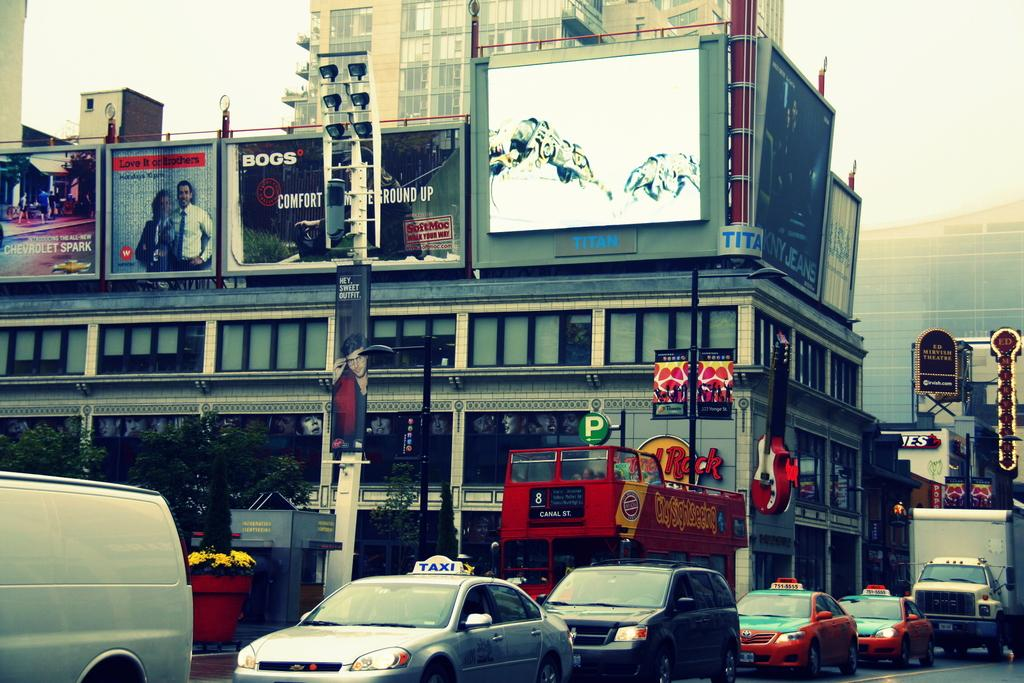<image>
Relay a brief, clear account of the picture shown. A billboard for Bogs sits among other signs on top of a city building. 